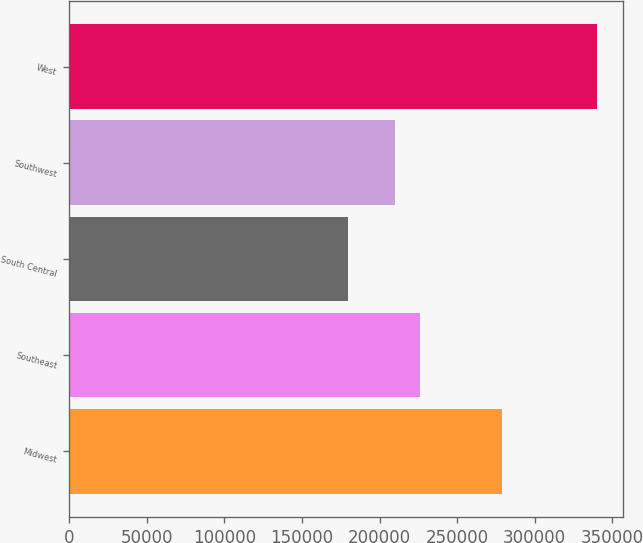Convert chart. <chart><loc_0><loc_0><loc_500><loc_500><bar_chart><fcel>Midwest<fcel>Southeast<fcel>South Central<fcel>Southwest<fcel>West<nl><fcel>279300<fcel>226120<fcel>179800<fcel>210100<fcel>340000<nl></chart> 